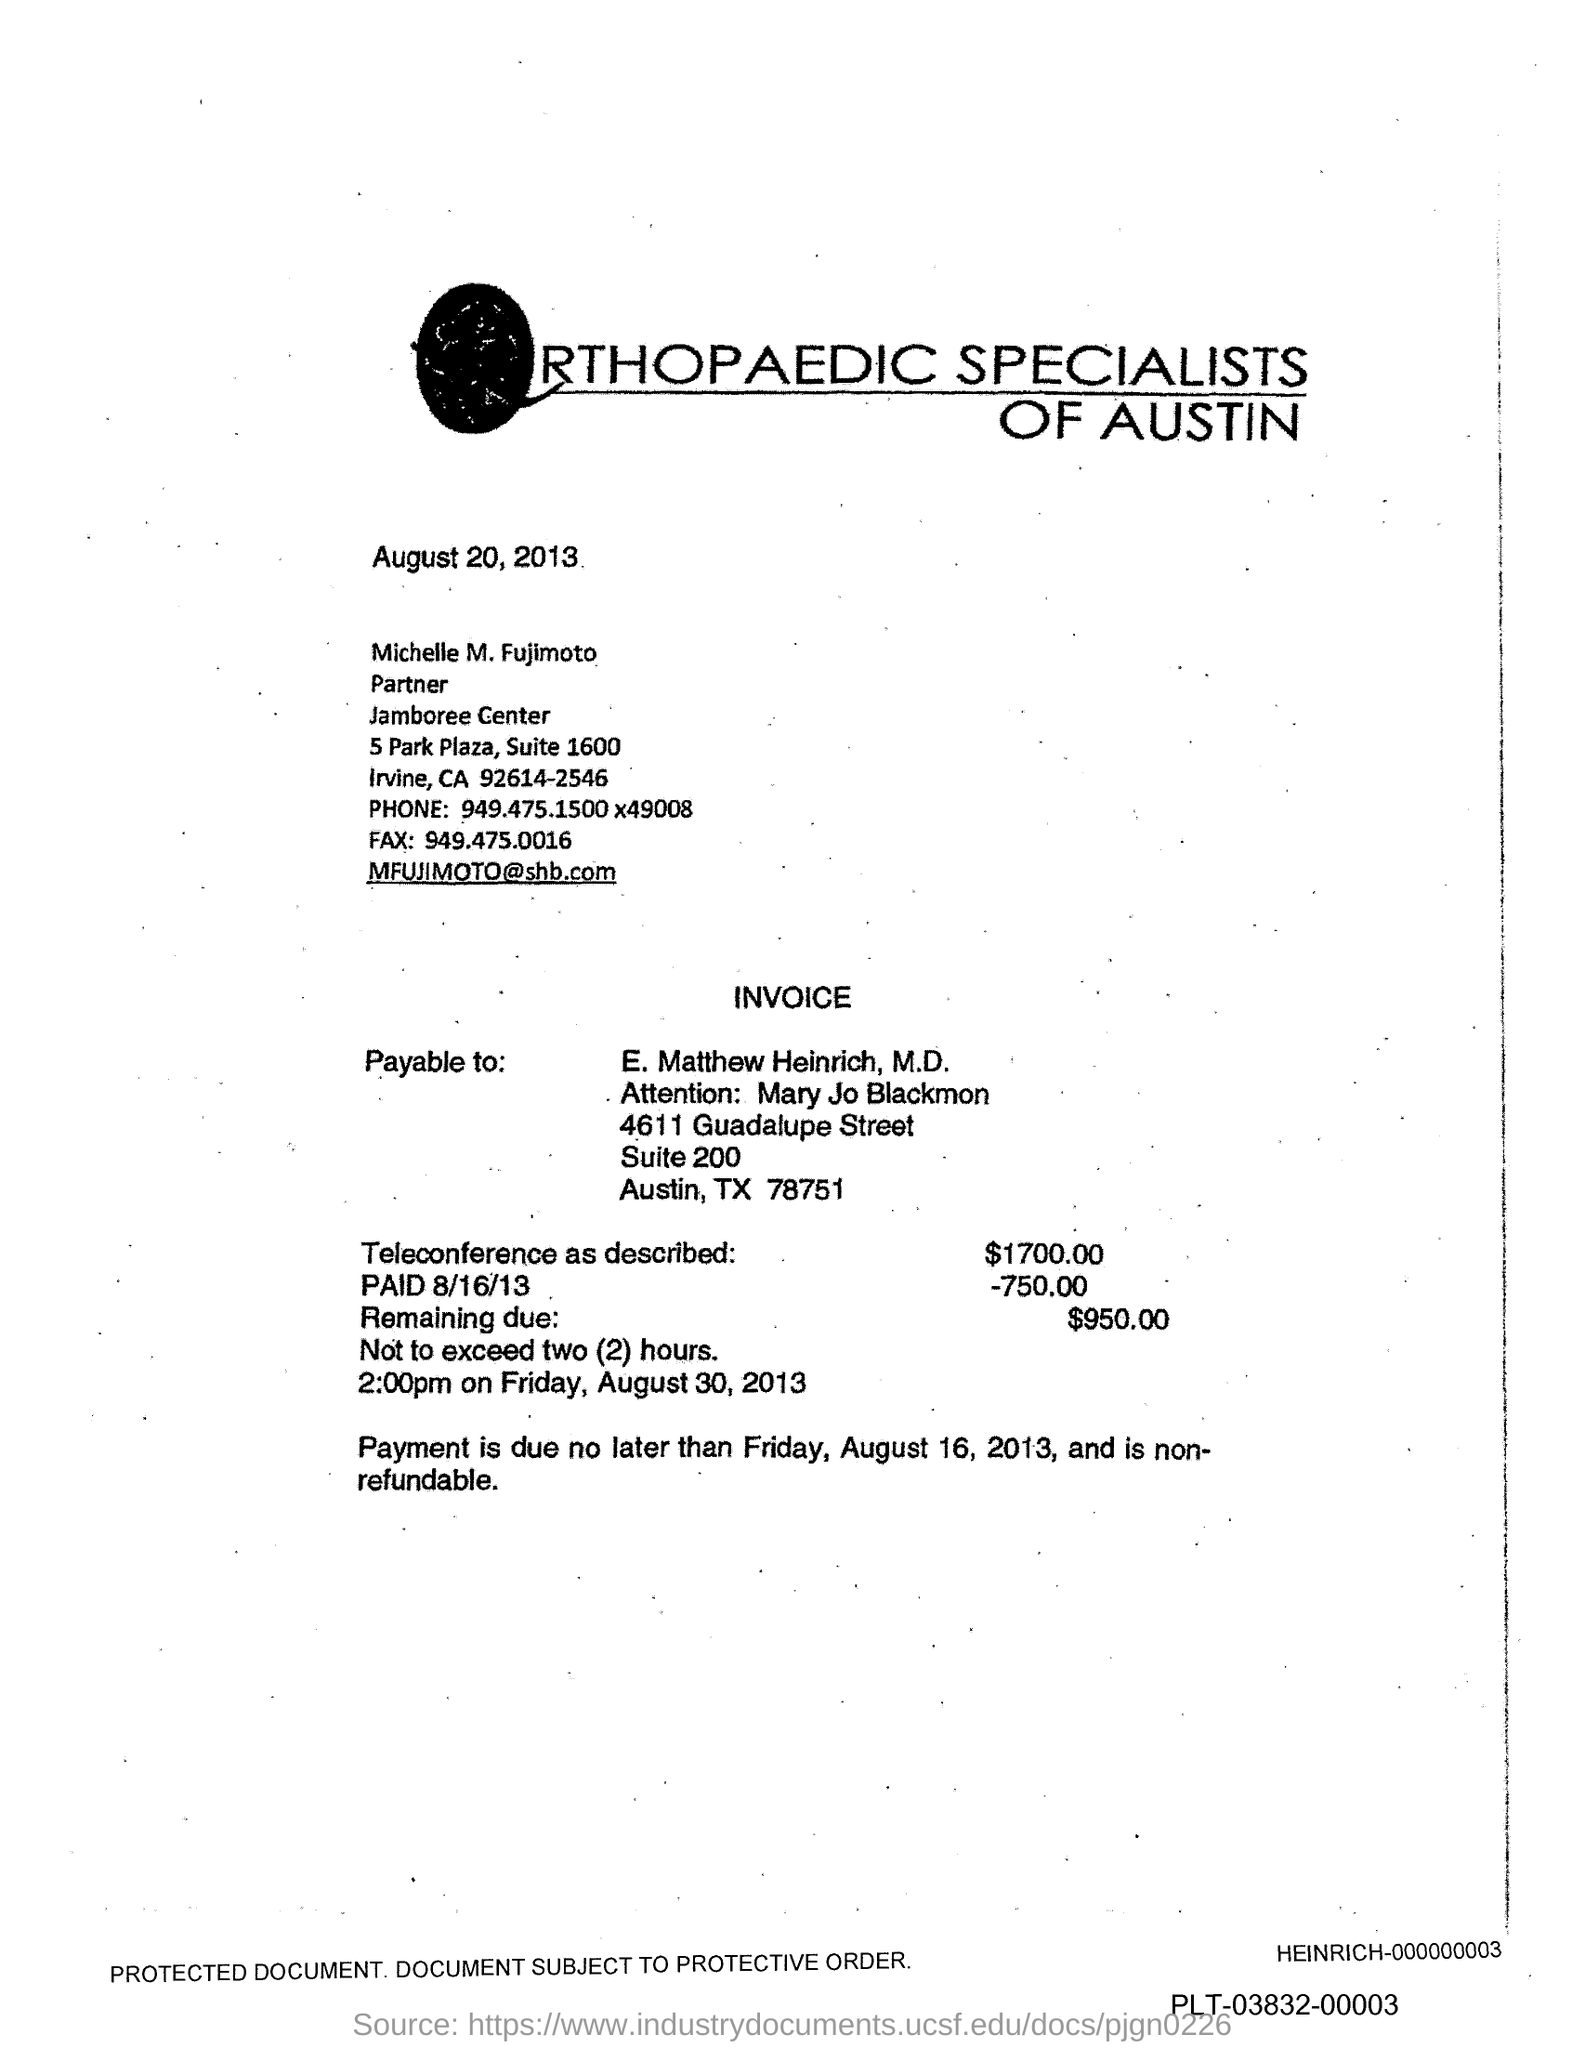Mention a couple of crucial points in this snapshot. The phone number mentioned in the document is 949.475.1500 x49008. The fax number is 949.475.0016. 